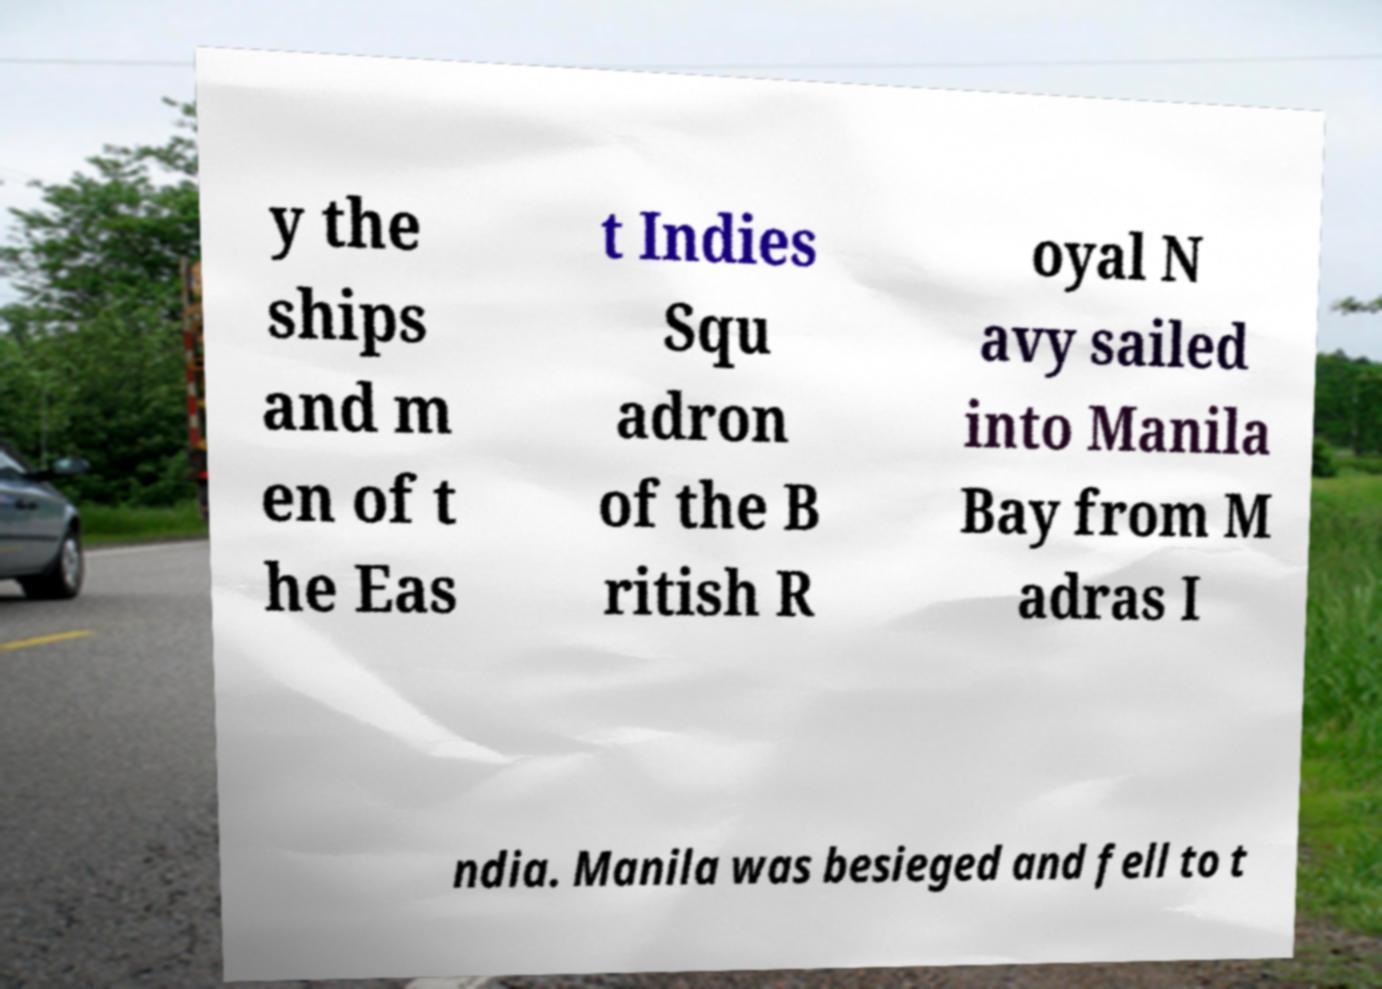I need the written content from this picture converted into text. Can you do that? y the ships and m en of t he Eas t Indies Squ adron of the B ritish R oyal N avy sailed into Manila Bay from M adras I ndia. Manila was besieged and fell to t 